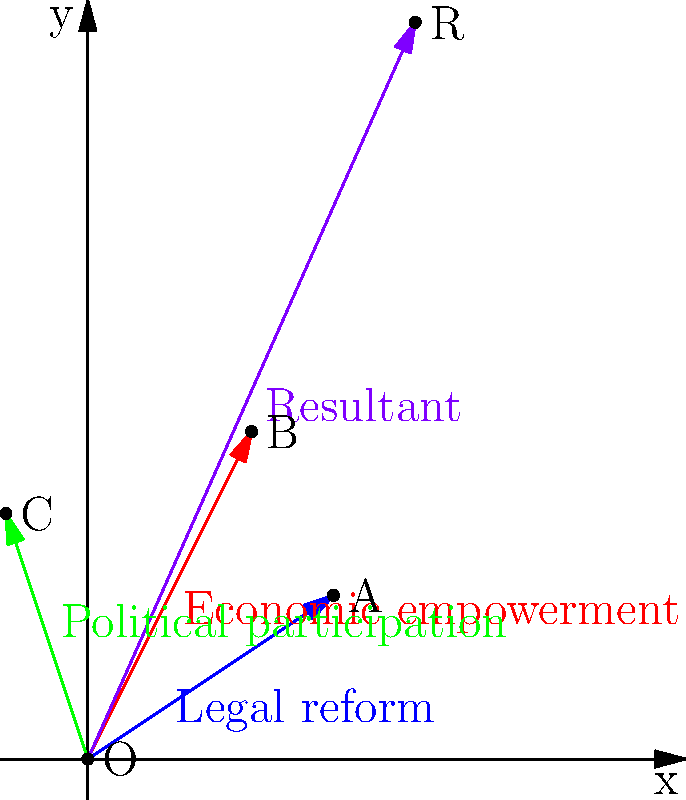In the global women's rights movement, three key vectors represent different aspects: legal reform (blue), economic empowerment (red), and political participation (green). If these vectors have magnitudes and directions as shown in the diagram, what is the magnitude of the resultant vector (purple) representing the combined impact of these movements? To find the magnitude of the resultant vector, we need to follow these steps:

1. Identify the components of each vector:
   Legal reform (v1): (3, 2)
   Economic empowerment (v2): (2, 4)
   Political participation (v3): (-1, 3)

2. Add the components to find the resultant vector (vr):
   vr_x = 3 + 2 + (-1) = 4
   vr_y = 2 + 4 + 3 = 9
   vr = (4, 9)

3. Calculate the magnitude of the resultant vector using the Pythagorean theorem:
   $$|vr| = \sqrt{vr_x^2 + vr_y^2}$$
   $$|vr| = \sqrt{4^2 + 9^2}$$
   $$|vr| = \sqrt{16 + 81}$$
   $$|vr| = \sqrt{97}$$

4. Simplify the square root:
   $$|vr| = \sqrt{97} \approx 9.85$$

Therefore, the magnitude of the resultant vector, representing the combined impact of these women's rights movements, is approximately 9.85 units.
Answer: $\sqrt{97}$ or approximately 9.85 units 